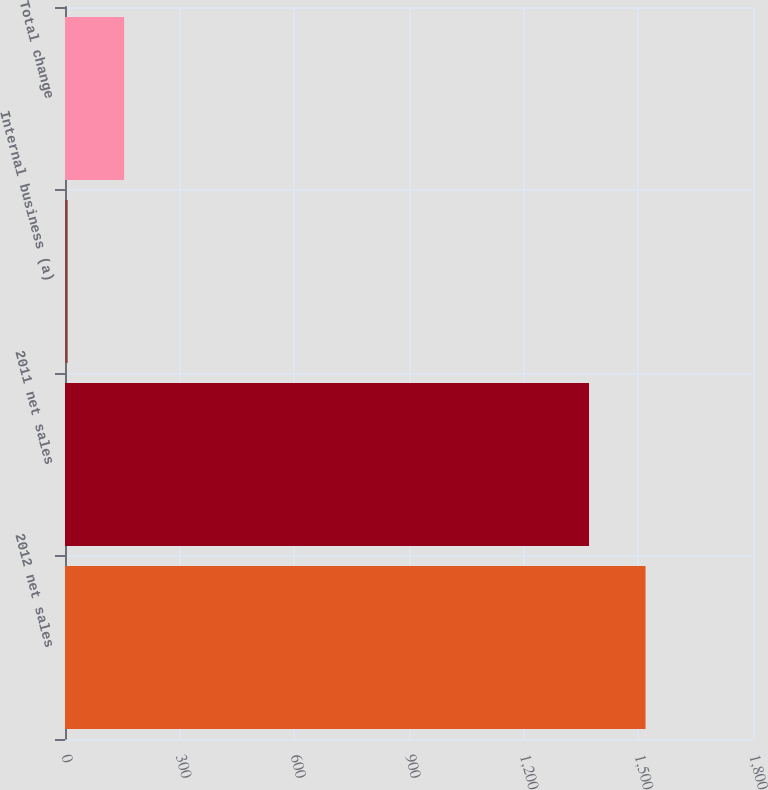Convert chart. <chart><loc_0><loc_0><loc_500><loc_500><bar_chart><fcel>2012 net sales<fcel>2011 net sales<fcel>Internal business (a)<fcel>Total change<nl><fcel>1518.8<fcel>1371<fcel>7<fcel>154.8<nl></chart> 